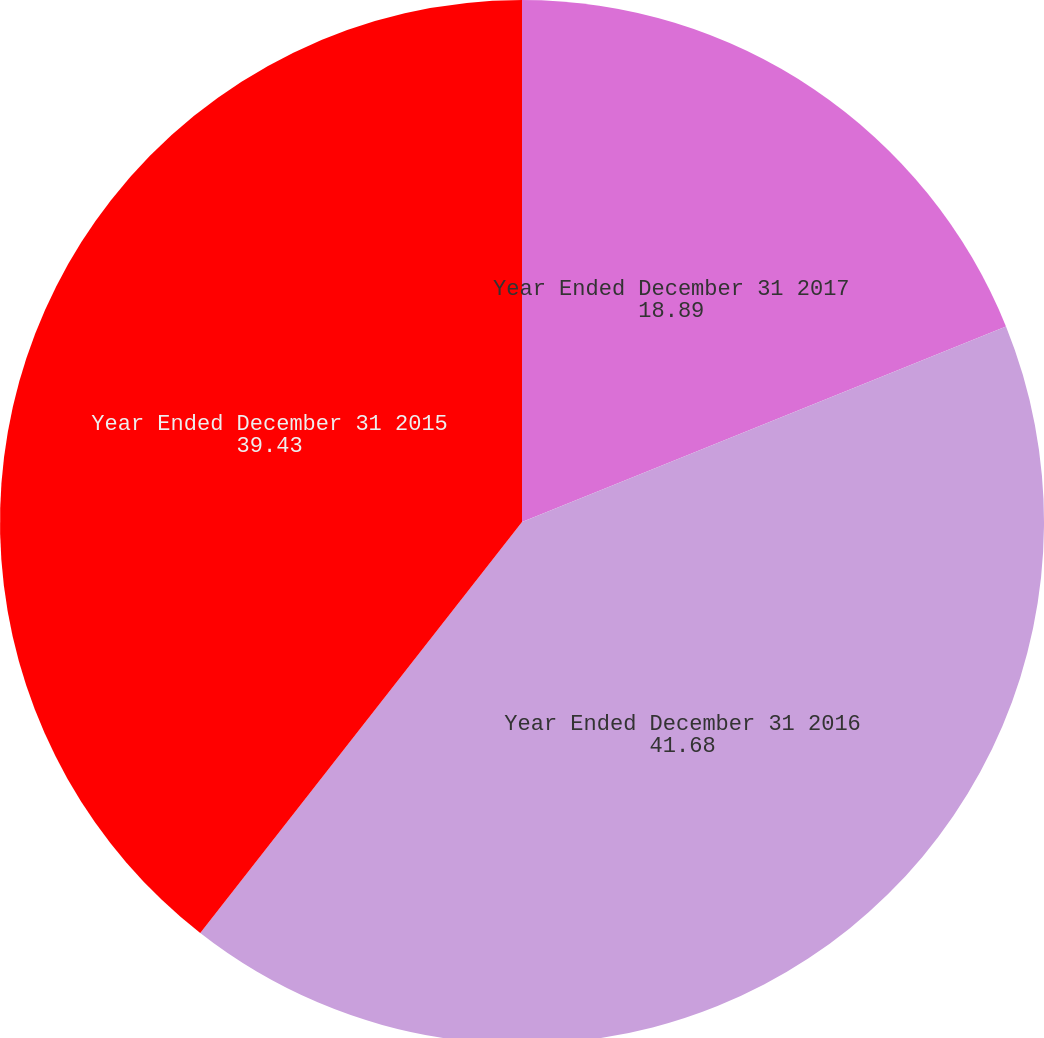<chart> <loc_0><loc_0><loc_500><loc_500><pie_chart><fcel>Year Ended December 31 2017<fcel>Year Ended December 31 2016<fcel>Year Ended December 31 2015<nl><fcel>18.89%<fcel>41.68%<fcel>39.43%<nl></chart> 